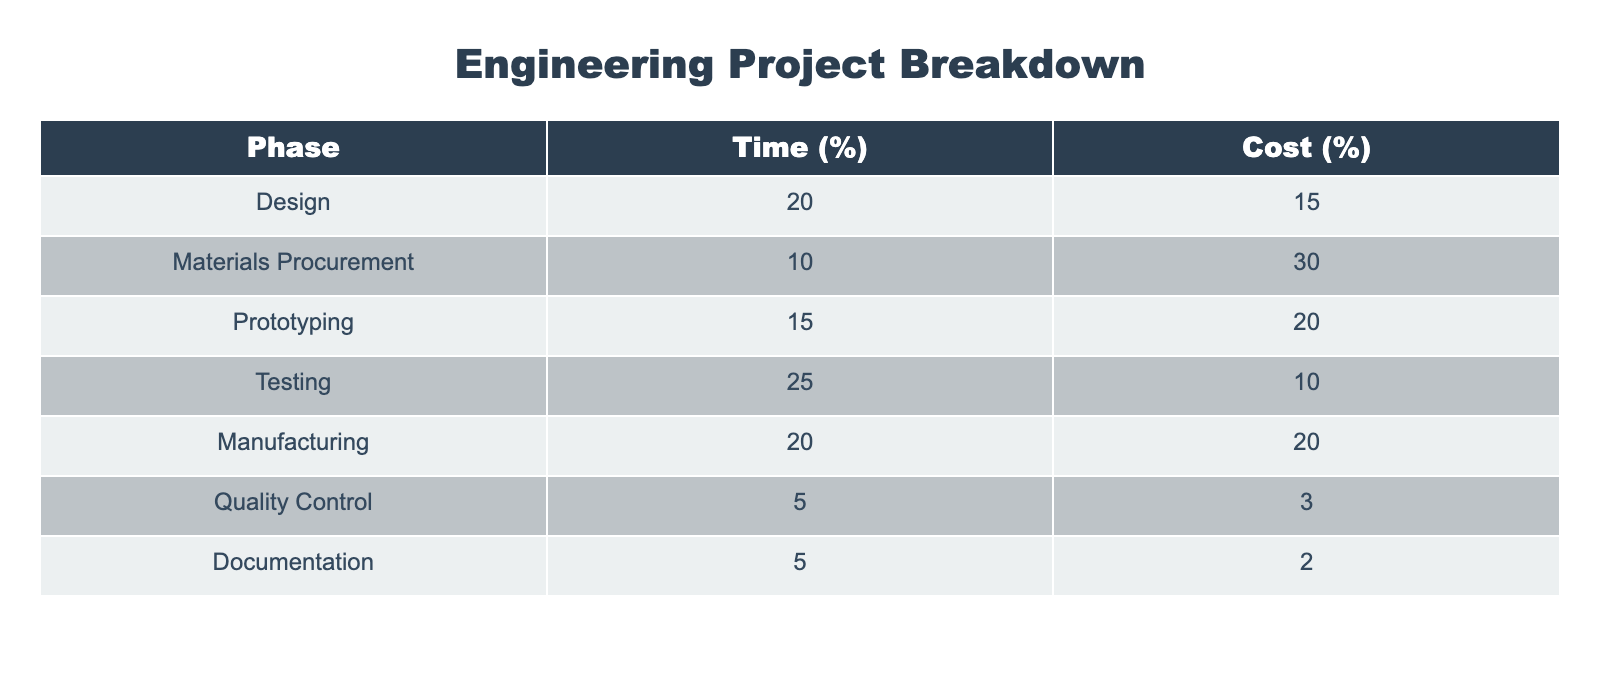What percentage of the total time is spent on testing? The table shows that testing accounts for 25% of the total time in an engineering project. This value is found directly in the "Time (%)" column under the Testing phase.
Answer: 25% Which phase has the highest cost percentage? By examining the "Cost (%)" column, Materials Procurement stands out with 30%, as it is greater than all other values in that column.
Answer: Materials Procurement What is the total percentage of time spent on prototyping and manufacturing? To find this, we need to add the time percentages for both phases: Prototyping (15%) and Manufacturing (20%). Adding them gives 15 + 20 = 35%.
Answer: 35% Is the percentage of time spent on documentation greater than the percentage of cost in the same phase? The documentation phase shows 5% for time and 2% for cost. Since 5% is greater than 2%, the statement is true.
Answer: Yes What is the average cost percentage across all phases? To find the average cost percentage, we need to sum all the cost percentages: 15 + 30 + 20 + 10 + 20 + 3 + 2 = 110%. There are 7 phases, so the average is 110/7 ≈ 15.71%.
Answer: 15.71% 